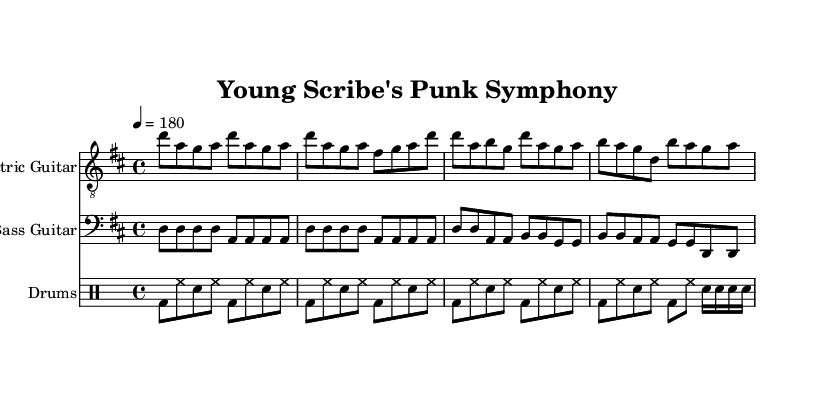What is the key signature of this music? The key signature is D major, which has two sharps (F# and C#). This can be determined by looking for the sharps indicated at the beginning of the staff.
Answer: D major What is the time signature of this piece? The time signature is 4/4, indicated at the beginning of the score as a fraction. This means there are four beats in each measure and the quarter note receives one beat.
Answer: 4/4 What is the tempo marking for this music? The tempo marking is 180 beats per minute, shown as "4 = 180" which indicates a relatively fast-paced speed for the piece.
Answer: 180 How many measures are in the intro section for the electric guitar? The intro section includes 4 measures, as counted from the beginning of the electric guitar notation until the transition to the verse section.
Answer: 4 What type of beat pattern is used in the drums part? The drums part employs a basic punk beat, characterized by a steady bass drum and snare pattern interspersed with hi-hat. This is typical for the punk genre, providing an energetic backdrop for the piece.
Answer: Basic punk beat What is the highest note played in the electric guitar part? The highest note played in the electric guitar part is D', which indicates it is the D note an octave higher than the middle C. This can be identified by reviewing the pitch notations in the melody.
Answer: D' How many different sections are there in the overall structure of the piece? There are four distinct sections in the piece: intro, verse, chorus, and bridge, each contributing to the overall punk structure and narrative. This can be determined by observing the labeled divisions in the music.
Answer: 4 